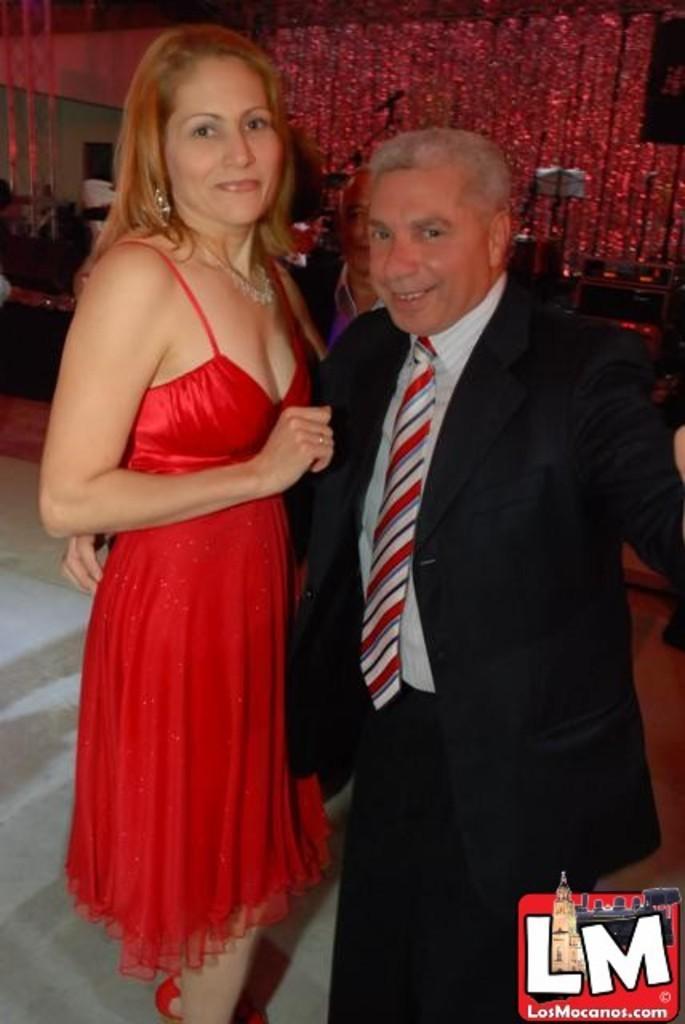Could you give a brief overview of what you see in this image? This image consists of a man and a woman. The woman is wearing a red dress. The man is wearing a black suit. At the bottom, there is a floor. In the background, there is a building. 